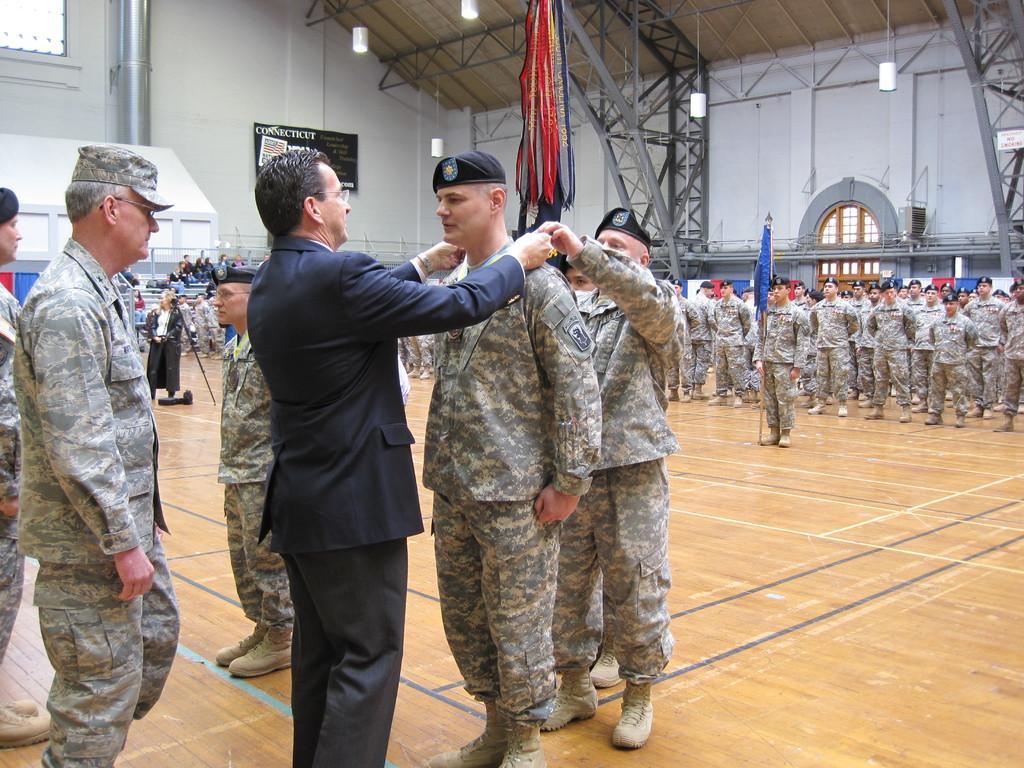Please provide a concise description of this image. In the foreground of this image, there is a man wearing suit and putting a medal to another man and we can also see few people standing on the wooden floor. In the background, there are people standing and a man is holding a flag. We can also see few people sitting on the stairs, wall, lights to the roof, window and few ribbon like objects at the top in the background. 